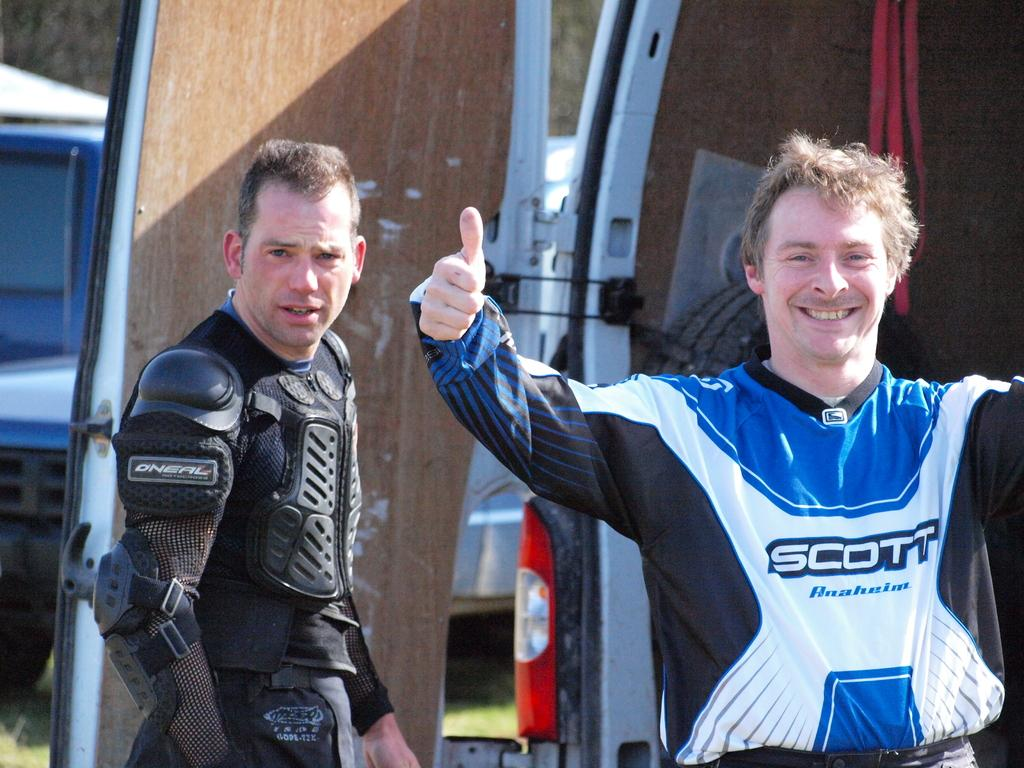<image>
Give a short and clear explanation of the subsequent image. A man giving a thumbs up signal and wearing a Motorsports uniform sponsored by Scott stands next to a man in a black uniform. 